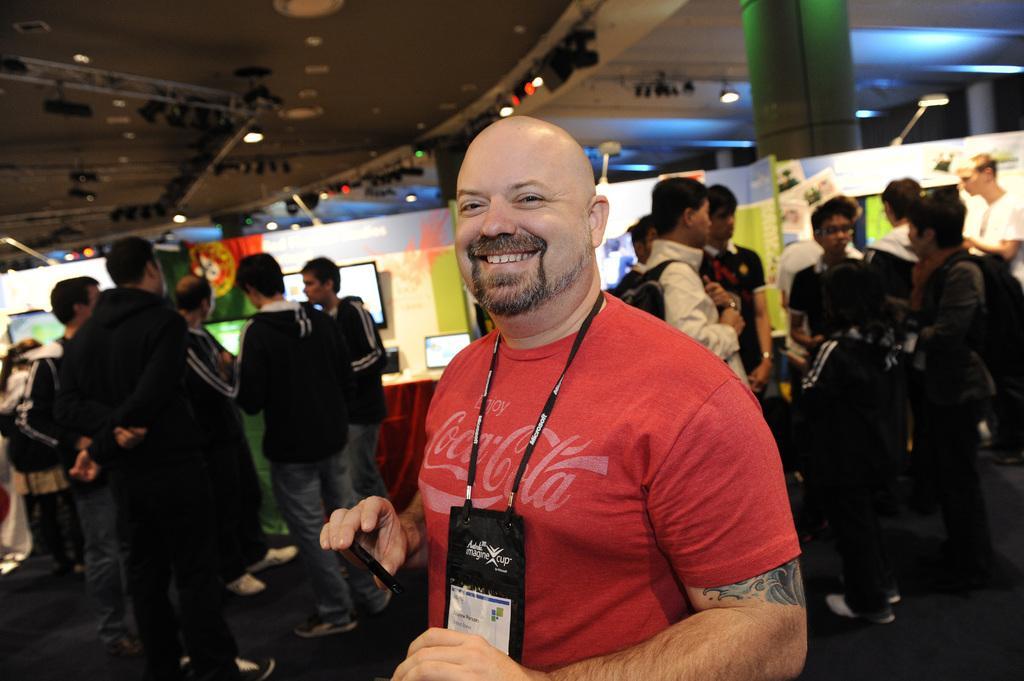Describe this image in one or two sentences. In the middle a man is standing, he is smiling, he wore a t-shirt. On the left side a group of people are standing and looking at that side. 